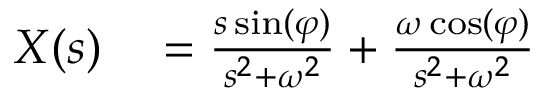<formula> <loc_0><loc_0><loc_500><loc_500>\begin{array} { r l } { X ( s ) } & = { \frac { s \sin ( \varphi ) } { s ^ { 2 } + \omega ^ { 2 } } } + { \frac { \omega \cos ( \varphi ) } { s ^ { 2 } + \omega ^ { 2 } } } } \end{array}</formula> 